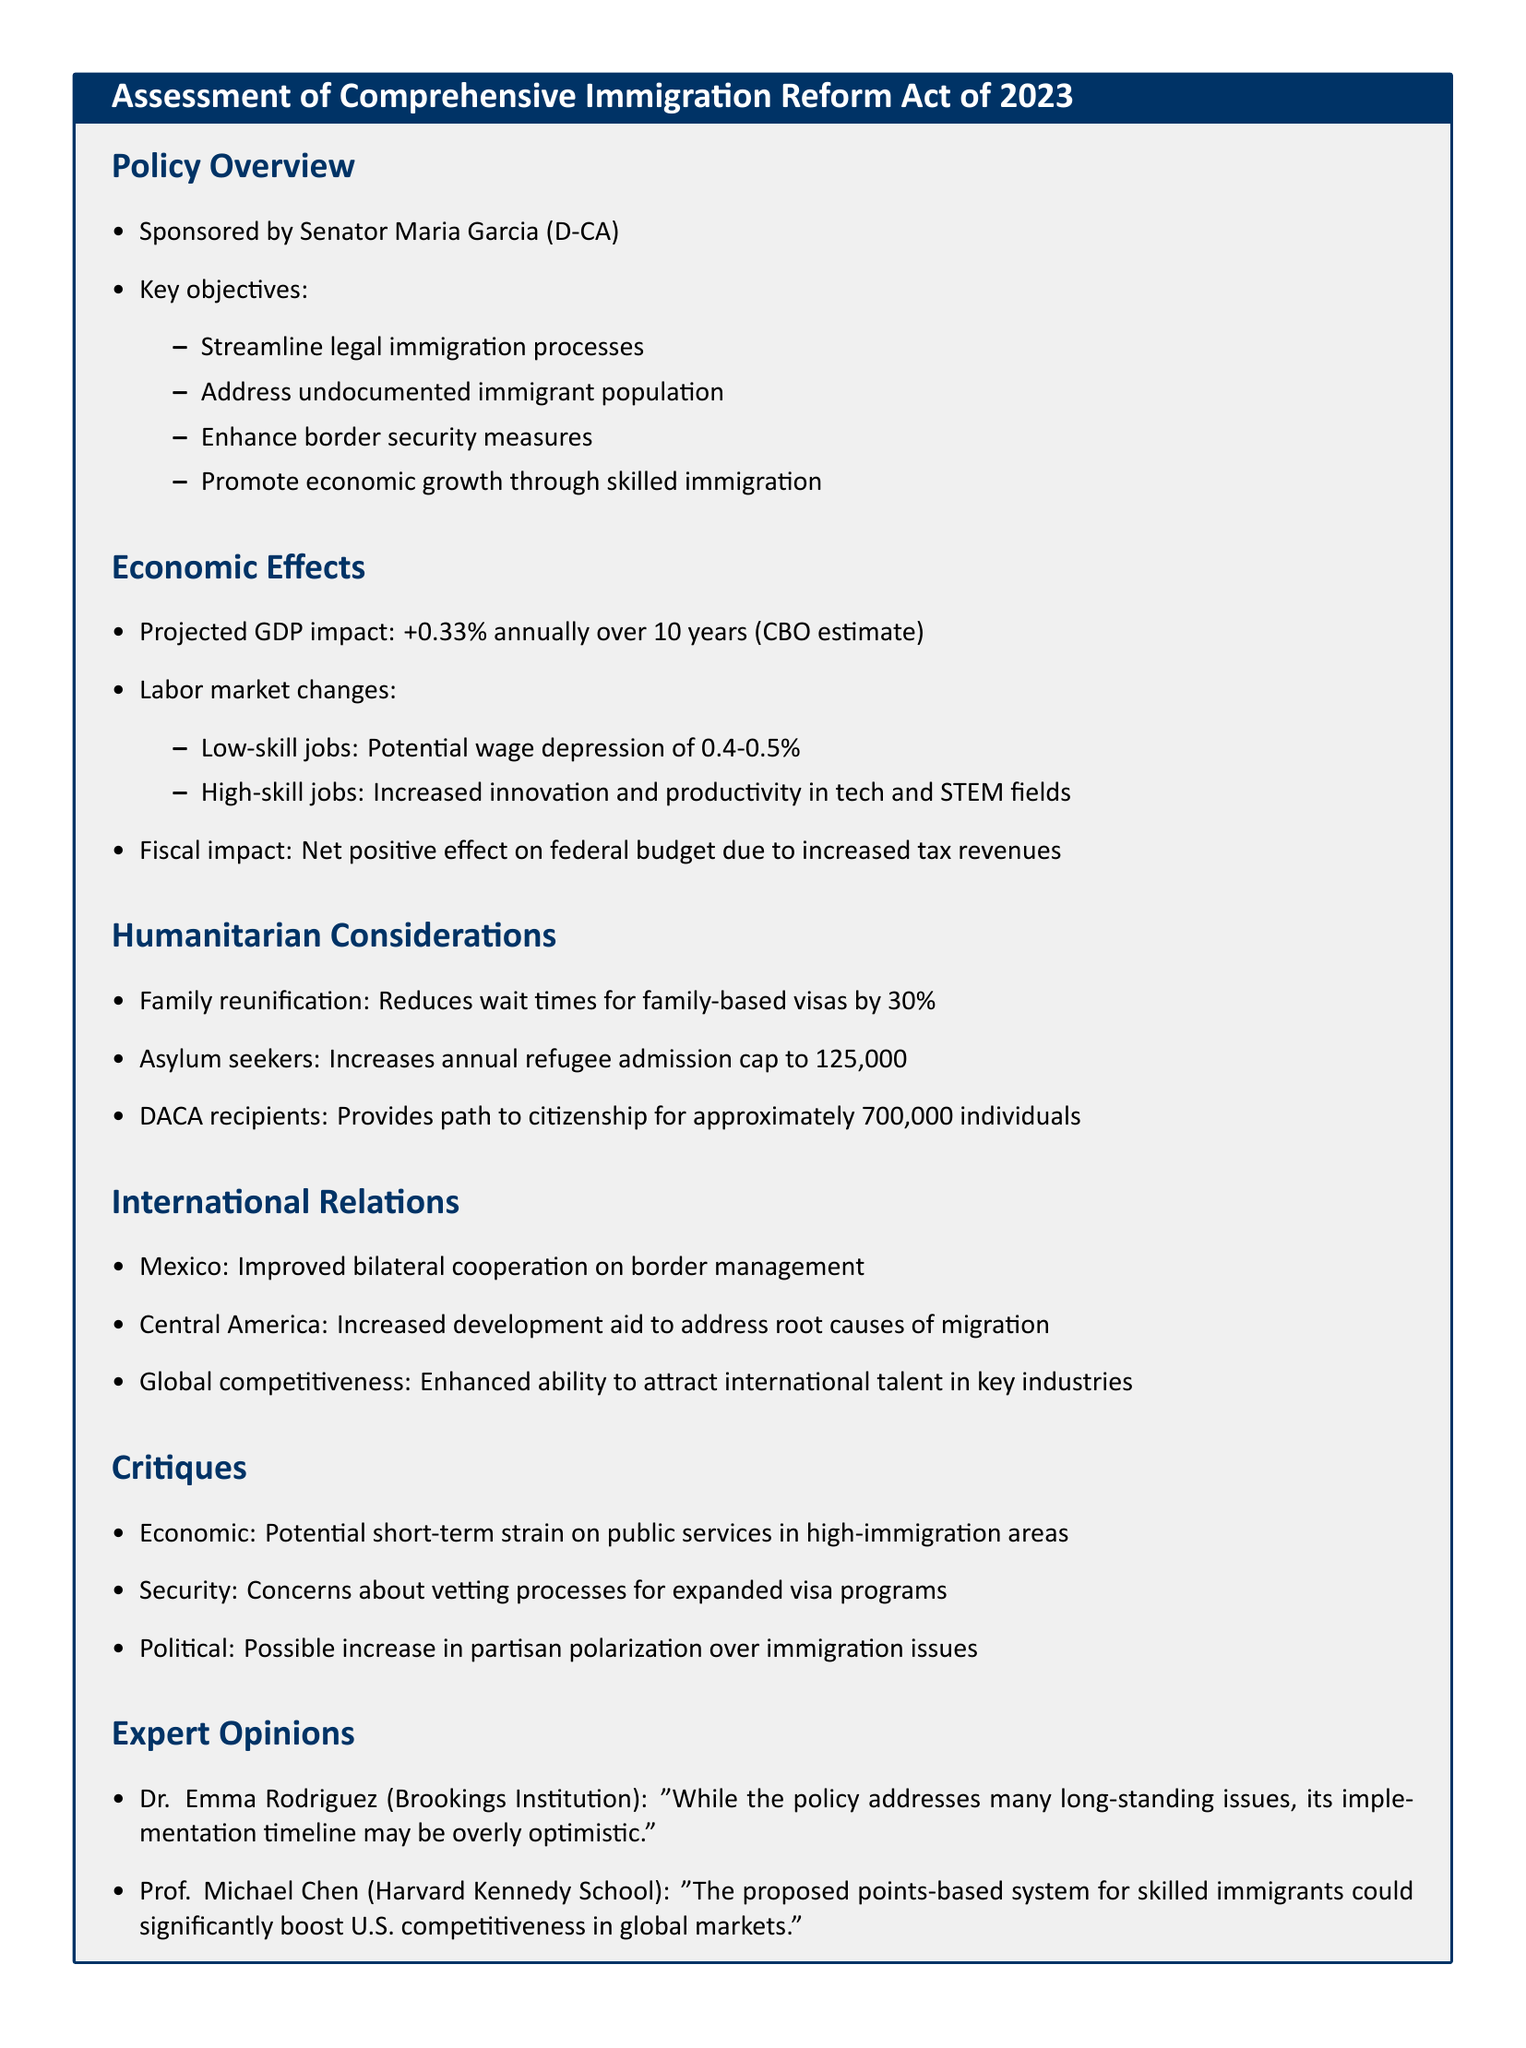What are the key objectives of the proposed policy? The key objectives are to streamline legal immigration processes, address undocumented immigrant population, enhance border security measures, and promote economic growth through skilled immigration.
Answer: Streamline legal immigration processes, address undocumented immigrant population, enhance border security measures, promote economic growth through skilled immigration What is the projected GDP impact of the policy? The projected GDP impact is mentioned as +0.33% annually over 10 years according to the CBO estimate.
Answer: +0.33% annually over 10 years How much does the policy increase the annual refugee admission cap? The document states that the policy increases the annual refugee admission cap to 125,000.
Answer: 125,000 How many DACA recipients could receive a path to citizenship? The document specifies that approximately 700,000 DACA recipients could receive a path to citizenship.
Answer: Approximately 700,000 What are the concerns regarding the expanded visa programs? The document highlights security concerns about vetting processes for expanded visa programs.
Answer: Vetting processes Does the document mention potential wage effects in low-skill jobs? Yes, it states that there could be a potential wage depression of 0.4-0.5% in low-skill jobs.
Answer: 0.4-0.5% Who sponsored the Comprehensive Immigration Reform Act of 2023? The document indicates that Senator Maria Garcia (D-CA) sponsored the act.
Answer: Senator Maria Garcia (D-CA) What expert opinion is provided regarding the implementation timeline? Dr. Emma Rodriguez expresses concern that the implementation timeline may be overly optimistic.
Answer: Overly optimistic What is one proposed benefit of the points-based system for skilled immigrants? Prof. Michael Chen notes that the proposed points-based system could significantly boost U.S. competitiveness in global markets.
Answer: Boost U.S. competitiveness in global markets 